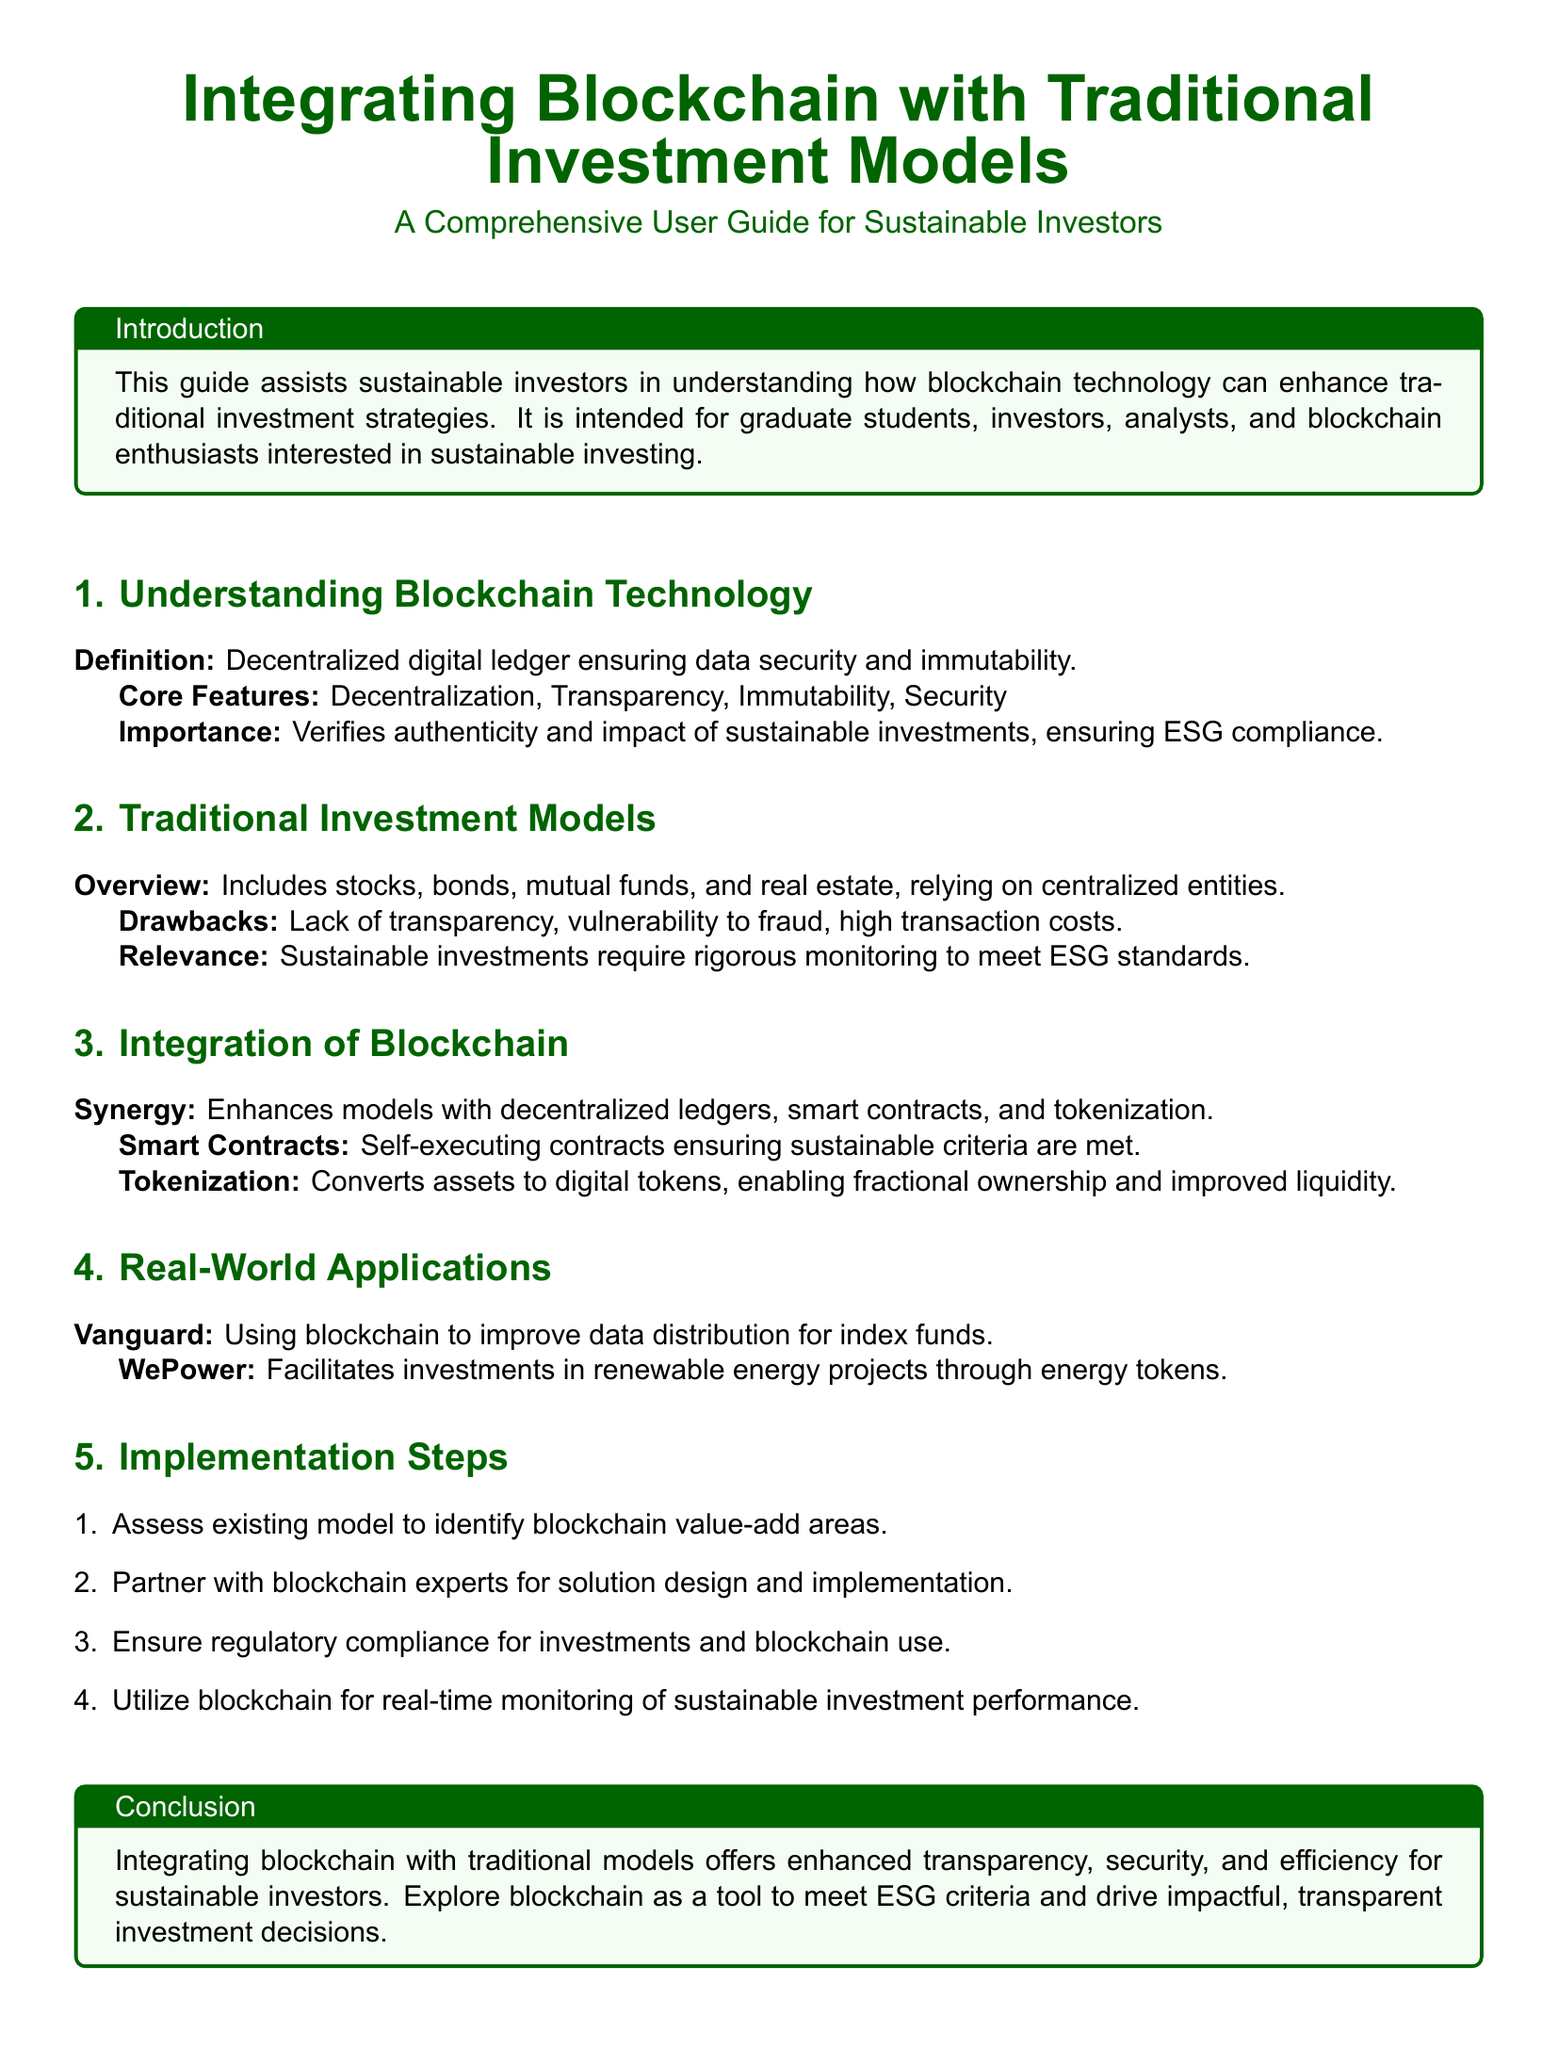What is the target audience for the guide? The guide is intended for graduate students, investors, analysts, and blockchain enthusiasts interested in sustainable investing.
Answer: Graduate students, investors, analysts, and blockchain enthusiasts What are the core features of blockchain technology? The core features of blockchain technology, as outlined, include decentralization, transparency, immutability, and security.
Answer: Decentralization, Transparency, Immutability, Security What is the drawback of traditional investment models? The document states that traditional investment models have a lack of transparency, vulnerability to fraud, and high transaction costs.
Answer: Lack of transparency, vulnerability to fraud, high transaction costs What is one real-world application of blockchain mentioned in the guide? The guide mentions Vanguard using blockchain to improve data distribution for index funds as a real-world application.
Answer: Vanguard How many implementation steps are outlined in the guide? The document outlines four implementation steps for integrating blockchain with traditional investment models.
Answer: Four What does tokenization allow according to the guide? Tokenization is explained to convert assets to digital tokens, enabling fractional ownership and improved liquidity.
Answer: Fractional ownership and improved liquidity What does the conclusion emphasize about integrating blockchain with traditional models? The conclusion emphasizes that integrating blockchain offers enhanced transparency, security, and efficiency for sustainable investors.
Answer: Enhanced transparency, security, and efficiency What is the first step in the implementation process? The first step in the implementation process is to assess the existing model to identify blockchain value-add areas.
Answer: Assess existing model to identify blockchain value-add areas 